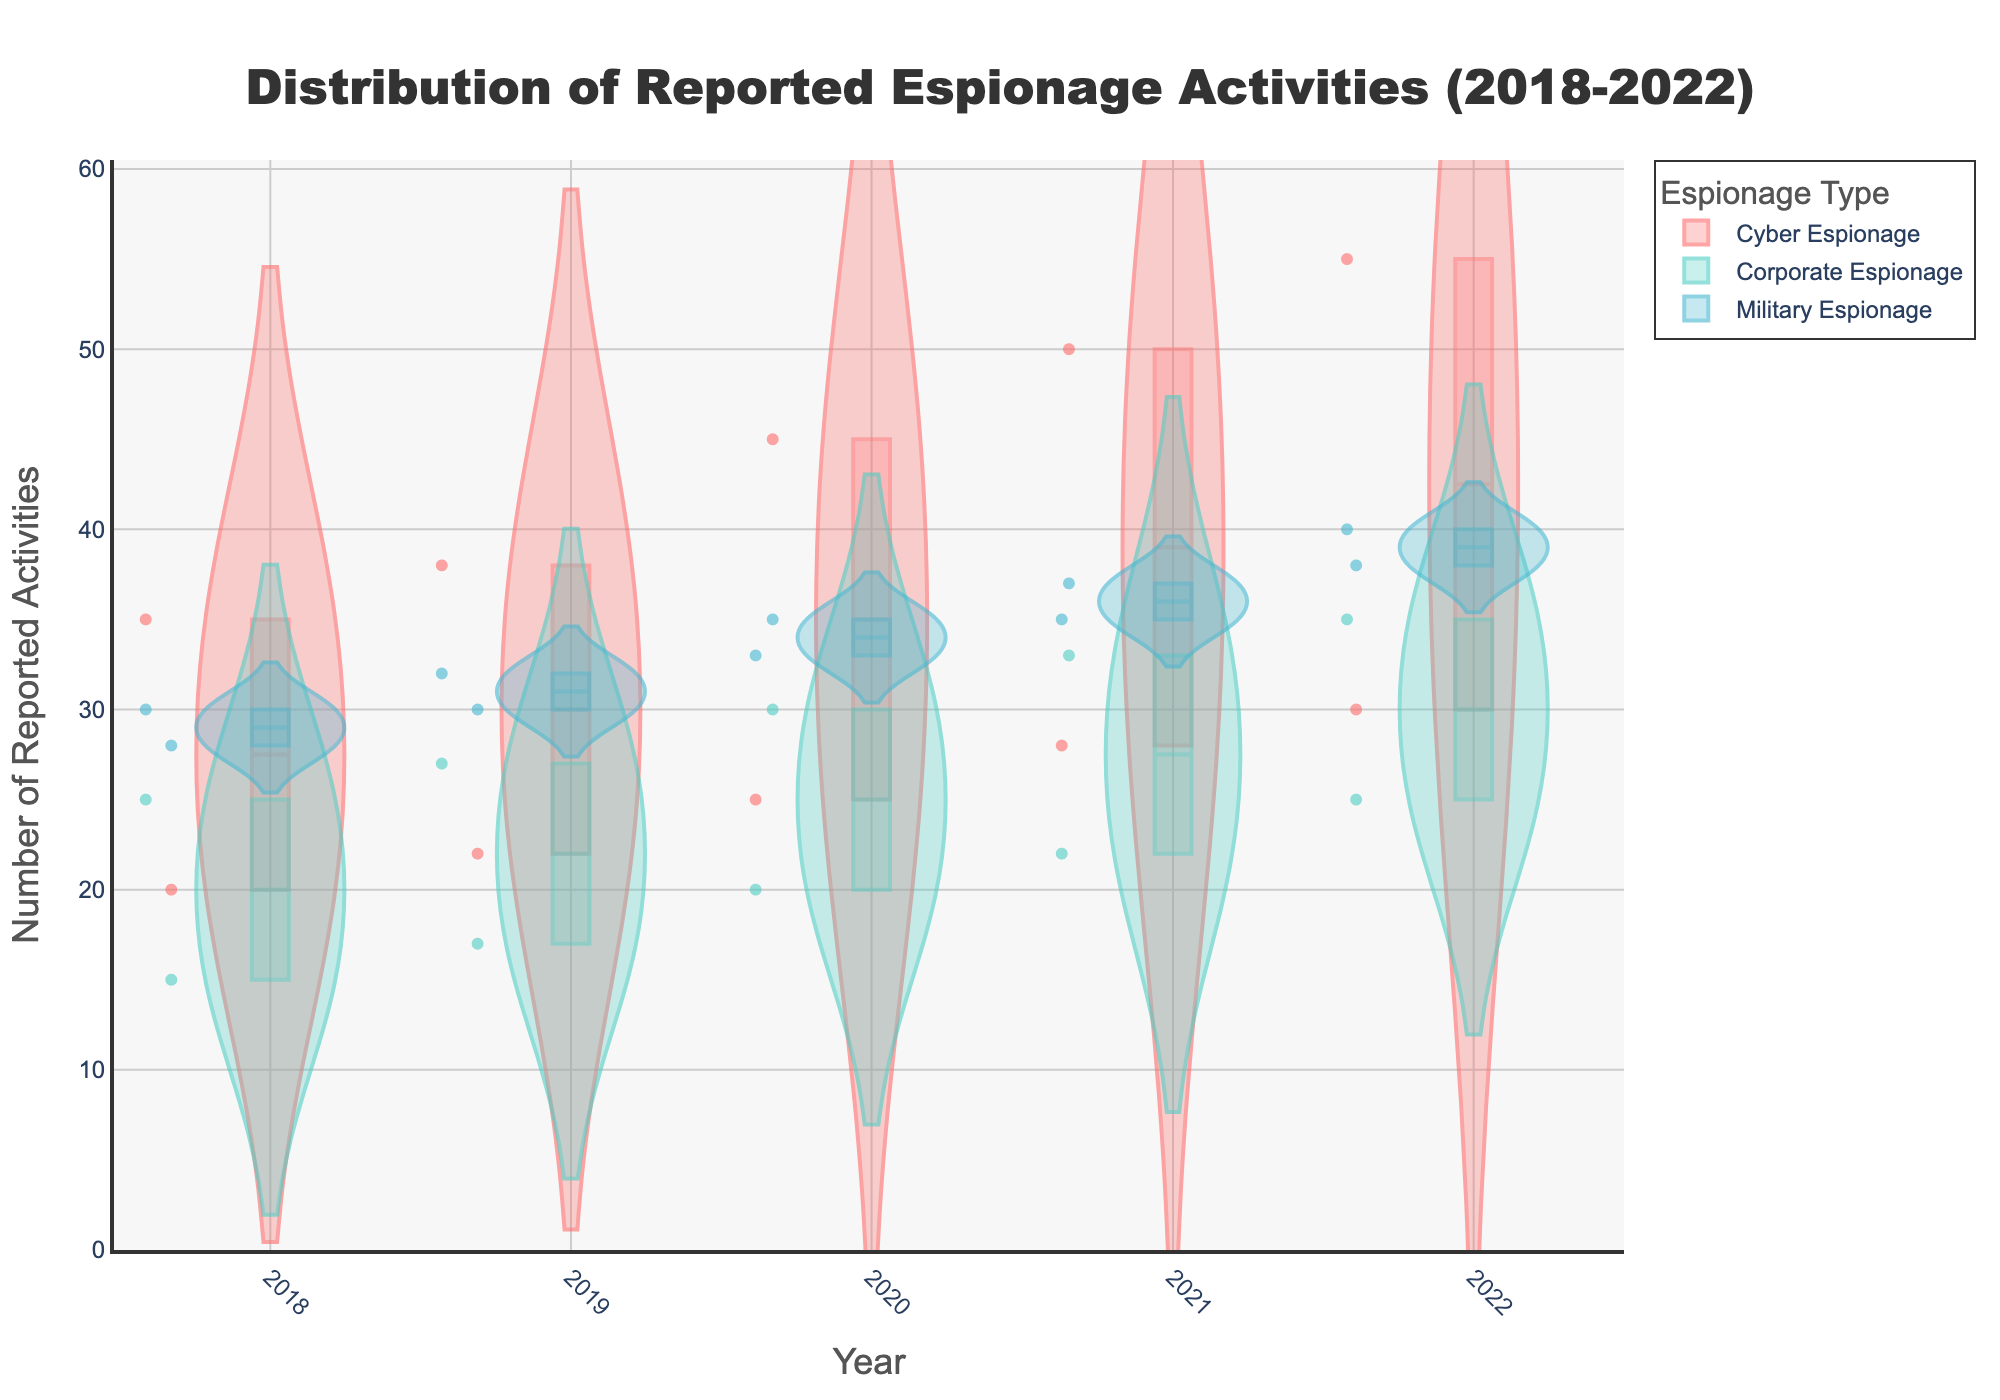What types of espionage activities are displayed in the plot? The plot includes three types of espionage activities which are shown through different colored violins.
Answer: Cyber Espionage, Corporate Espionage, Military Espionage How is the trend of Cyber Espionage in the United States from 2018 to 2022? By looking at the violin plot for Cyber Espionage in the United States year-over-year, it shows an increasing number of reported activities. The count rises from 2018 to 2022.
Answer: Increasing Which year shows the highest count of Military Espionage in Iran? By examining the data points on the violin plots for Military Espionage, it's clear that the highest count occurs in 2022.
Answer: 2022 How does Corporate Espionage activity in Germany compare to China over the last five years? By comparing the boxes within the violin plots, Corporate Espionage activity is generally higher in China compared to Germany throughout the five years.
Answer: Higher in China What is the average count of Cyber Espionage in Russia from 2018 to 2022? The counts for each year 2018 to 2022 are {20, 22, 25, 28, 30}. Add these and then divide by the number of years (5). (20+22+25+28+30)/5 = 25
Answer: 25 Describe the distribution shape of Military Espionage reported activities in North Korea over the last five years? The violin plot for Military Espionage in North Korea over the last five years shows a relatively symmetric distribution with counts between 28 to 38.
Answer: Symmetric Which espionage type shows the widest spread in reported activities? By observing the width of the violins, Cyber Espionage seems to have the widest spread, evident from the varied counts in the plot.
Answer: Cyber Espionage How many data points are shown for Corporate Espionage in total? Summing up the data points for Germany and China from 2018 to 2022: (15+17+20+22+25) for Germany and (25+27+30+33+35) for China, making it 109 data points total.
Answer: 109 Out of the three espionage types, which one has the least variance over the years? Comparing the width and range of the violin plots, Military Espionage appears to have the least variance.
Answer: Military Espionage Does the average number of reported espionage activities increase or decrease for Cyber Espionage over the years? By calculating the average counts for each year 2018 to 2022 across all locations, it shows an overall increasing trend.
Answer: Increase 